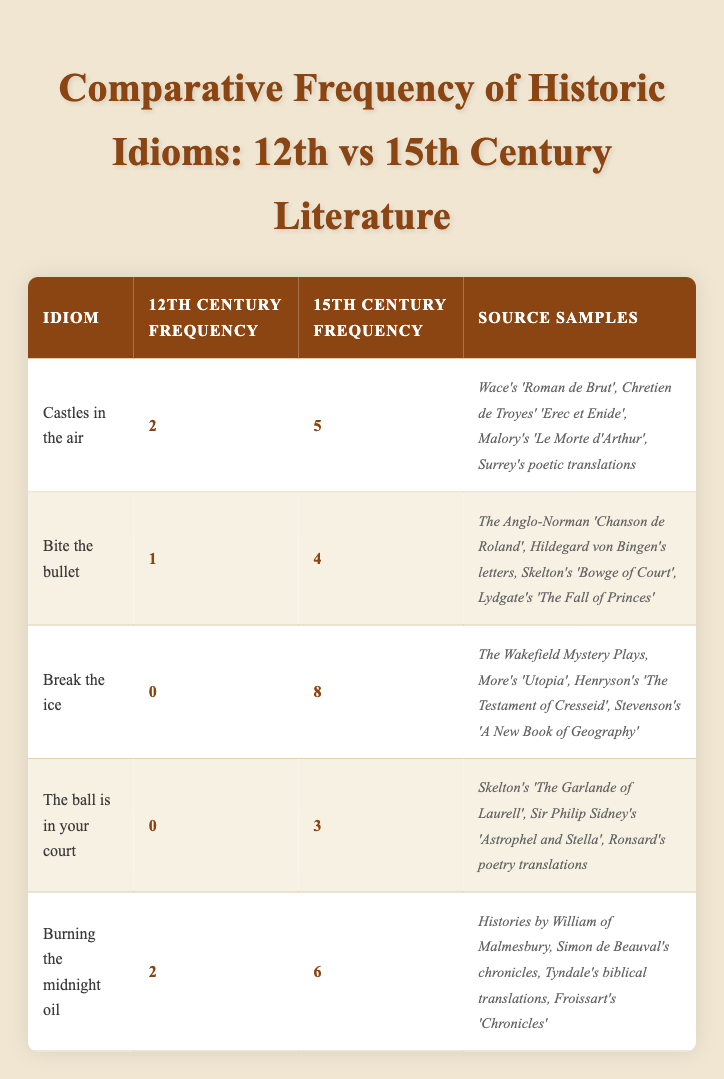What was the frequency of "Burning the midnight oil" in the 12th century? According to the table, the frequency of the idiom "Burning the midnight oil" in the 12th century is recorded as 2.
Answer: 2 How many historical idioms had a frequency of zero in the 12th century? The idioms "Break the ice" and "The ball is in your court" both show a frequency of 0 in the 12th century. Therefore, there are 2 idioms with a frequency of zero.
Answer: 2 What is the difference in frequency for "Castles in the air" between the 12th and 15th centuries? The frequency of "Castles in the air" in the 12th century is 2 and in the 15th century is 5. The difference is calculated as 5 - 2 = 3.
Answer: 3 Did "Break the ice" appear in the 12th century? The table shows a frequency of 0 for "Break the ice" in the 12th century, indicating that this idiom did not appear at all during that time.
Answer: No Which idiom had the highest frequency in the 15th century? The idiom "Break the ice" had the highest frequency of 8 in the 15th century compared to others, as shown in the table.
Answer: Break the ice How many idioms had a higher frequency in the 15th century compared to the 12th century? By examining the table, we find that "Castles in the air," "Bite the bullet," "Break the ice," "The ball is in your court," and "Burning the midnight oil" all have higher frequencies in the 15th century compared to the 12th century. This totals to 5 idioms.
Answer: 5 